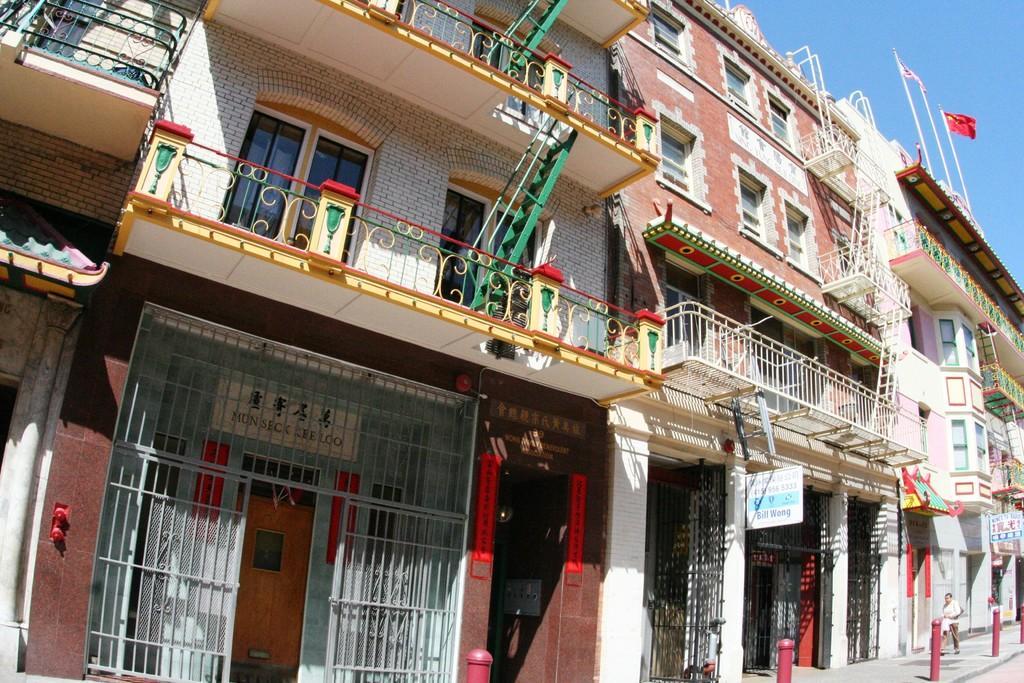In one or two sentences, can you explain what this image depicts? In this image we can see a group of buildings with windows, railings, staircase and some sign boards with some text. On the right side of the image we can see a person standing on the ground, group of metal poles and some flags on poles. At the top of the image we can see the sky. 